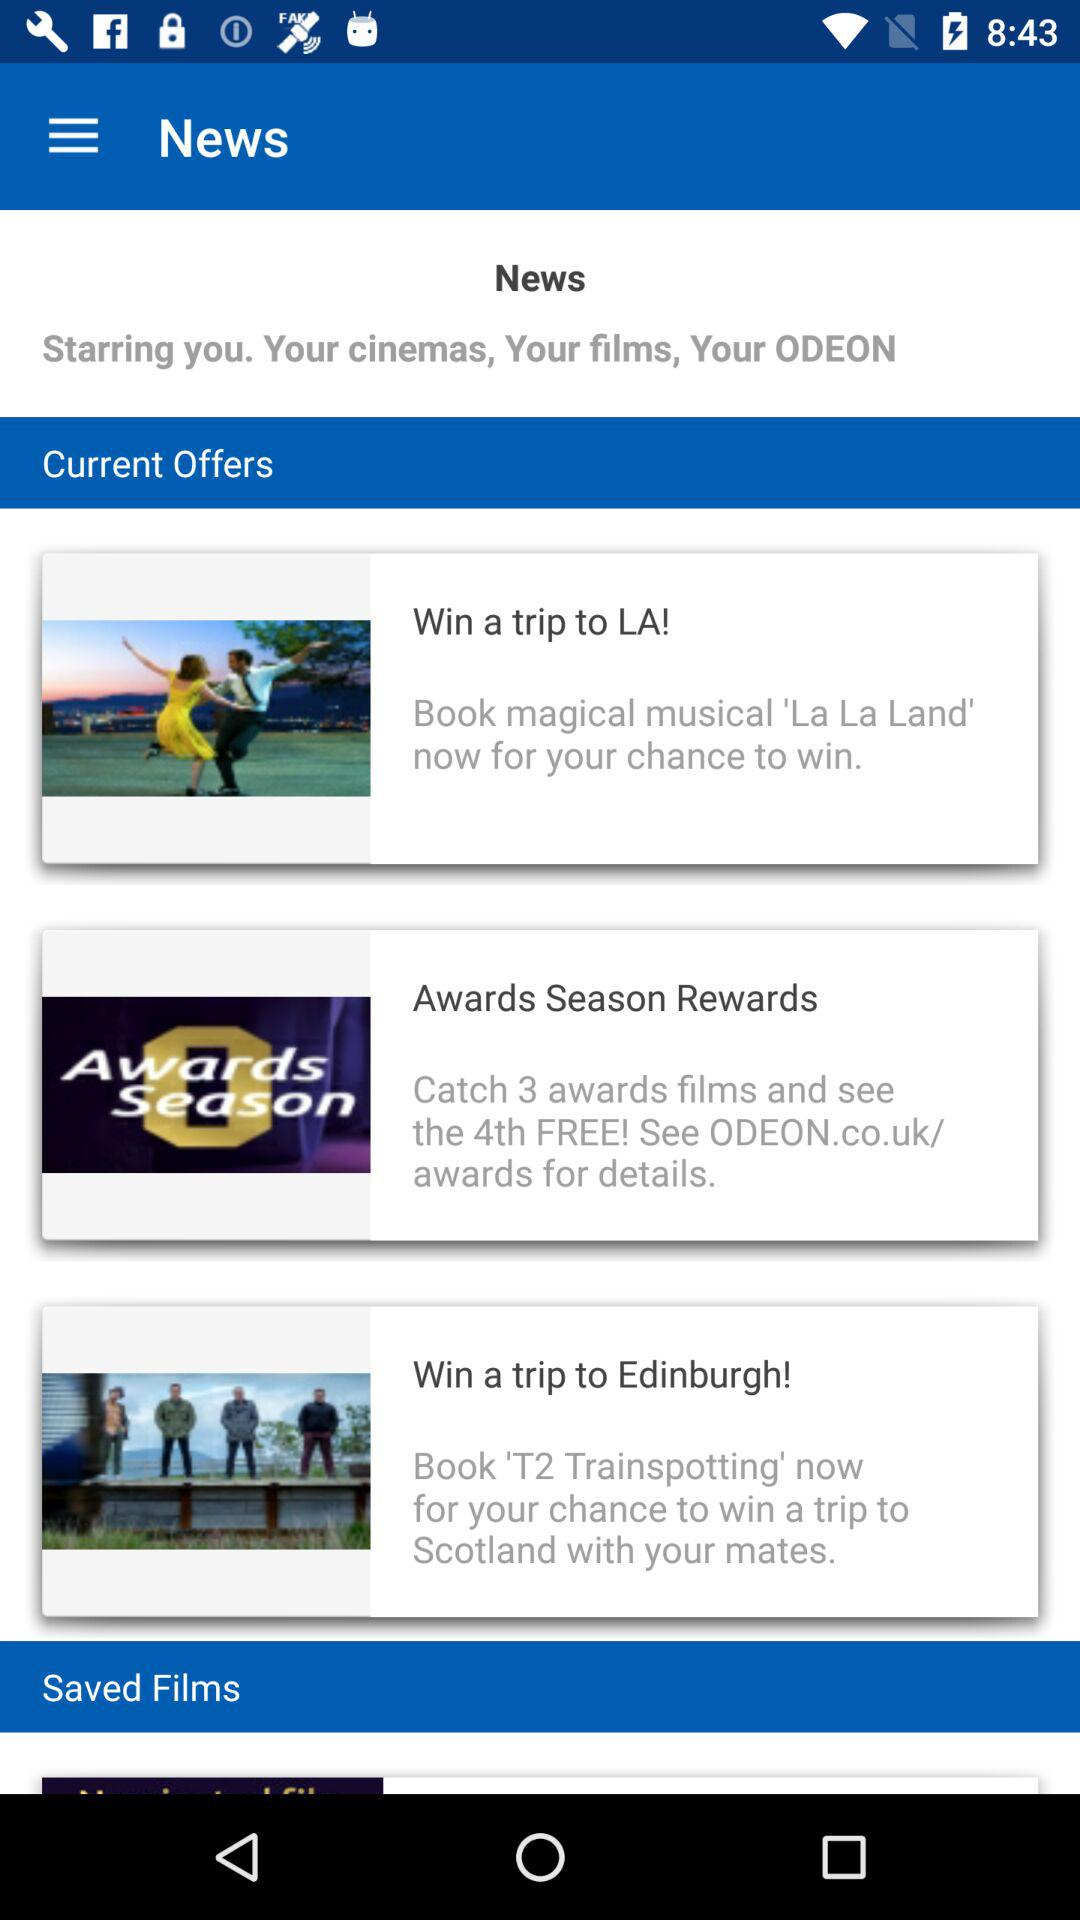What are the current offers? The current offers are "Win a trip to LA!", "Awards Season Rewards" and "Win a trip to Edinburgh!". 